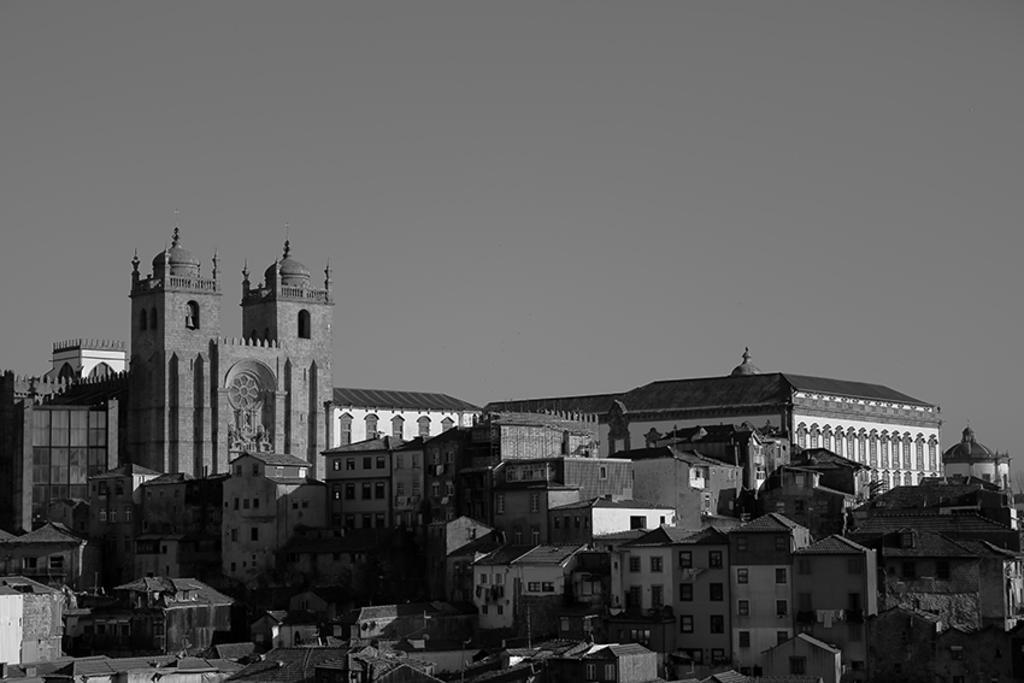Can you describe this image briefly? In this picture I can see many buildings, monuments, shed and church. At the top there is a sky. At the bottom, on the roof of the building I can see some poles. 